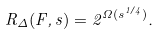<formula> <loc_0><loc_0><loc_500><loc_500>R _ { \Delta } ( F , s ) = 2 ^ { \Omega ( s ^ { 1 / 4 } ) } .</formula> 